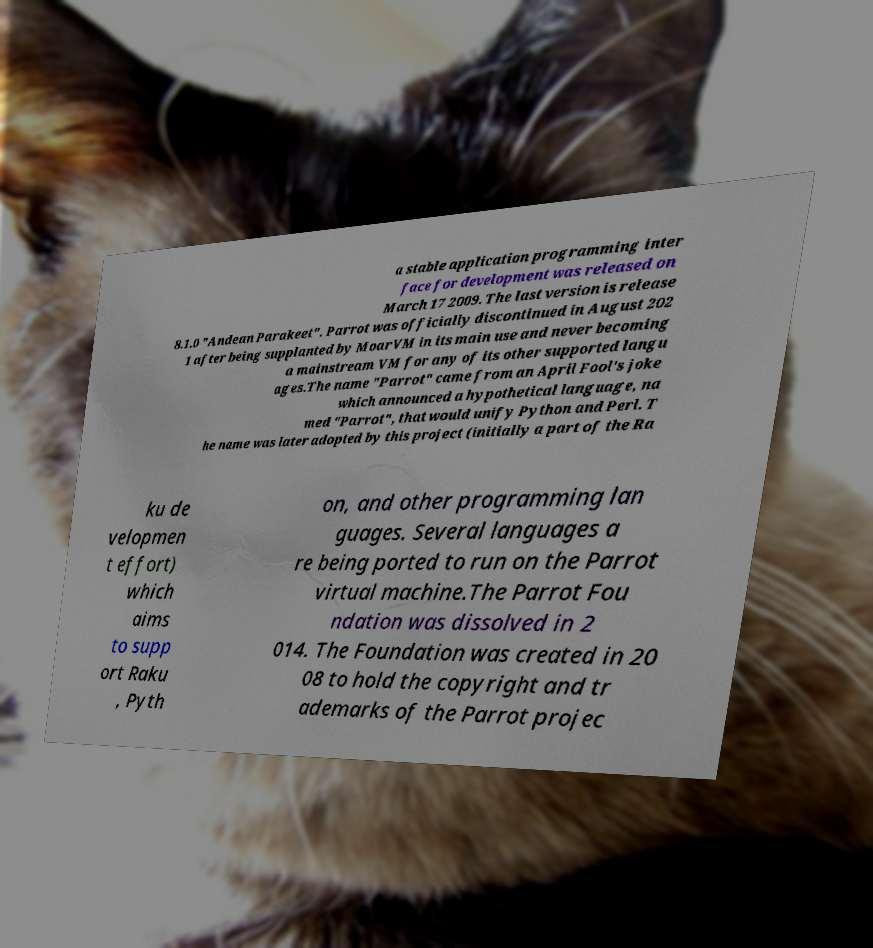Could you extract and type out the text from this image? a stable application programming inter face for development was released on March 17 2009. The last version is release 8.1.0 "Andean Parakeet". Parrot was officially discontinued in August 202 1 after being supplanted by MoarVM in its main use and never becoming a mainstream VM for any of its other supported langu ages.The name "Parrot" came from an April Fool's joke which announced a hypothetical language, na med "Parrot", that would unify Python and Perl. T he name was later adopted by this project (initially a part of the Ra ku de velopmen t effort) which aims to supp ort Raku , Pyth on, and other programming lan guages. Several languages a re being ported to run on the Parrot virtual machine.The Parrot Fou ndation was dissolved in 2 014. The Foundation was created in 20 08 to hold the copyright and tr ademarks of the Parrot projec 